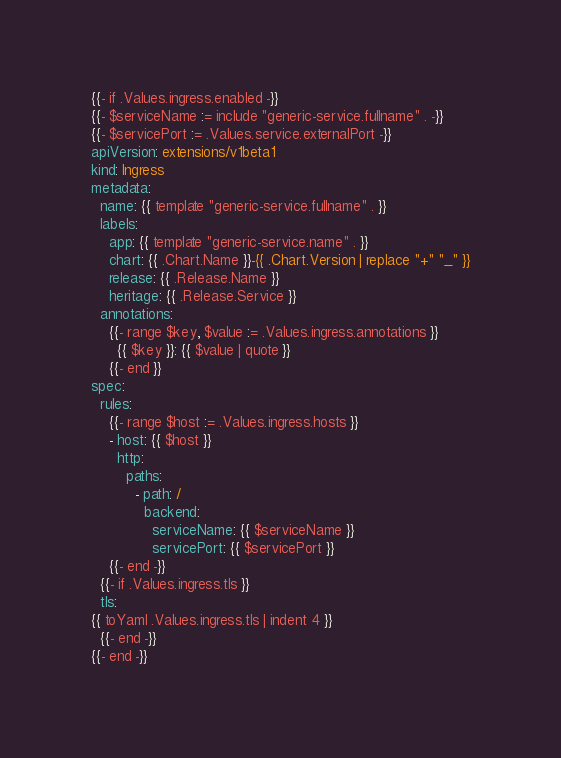<code> <loc_0><loc_0><loc_500><loc_500><_YAML_>{{- if .Values.ingress.enabled -}}
{{- $serviceName := include "generic-service.fullname" . -}}
{{- $servicePort := .Values.service.externalPort -}}
apiVersion: extensions/v1beta1
kind: Ingress
metadata:
  name: {{ template "generic-service.fullname" . }}
  labels:
    app: {{ template "generic-service.name" . }}
    chart: {{ .Chart.Name }}-{{ .Chart.Version | replace "+" "_" }}
    release: {{ .Release.Name }}
    heritage: {{ .Release.Service }}
  annotations:
    {{- range $key, $value := .Values.ingress.annotations }}
      {{ $key }}: {{ $value | quote }}
    {{- end }}
spec:
  rules:
    {{- range $host := .Values.ingress.hosts }}
    - host: {{ $host }}
      http:
        paths:
          - path: /
            backend:
              serviceName: {{ $serviceName }}
              servicePort: {{ $servicePort }}
    {{- end -}}
  {{- if .Values.ingress.tls }}
  tls:
{{ toYaml .Values.ingress.tls | indent 4 }}
  {{- end -}}
{{- end -}}
</code> 